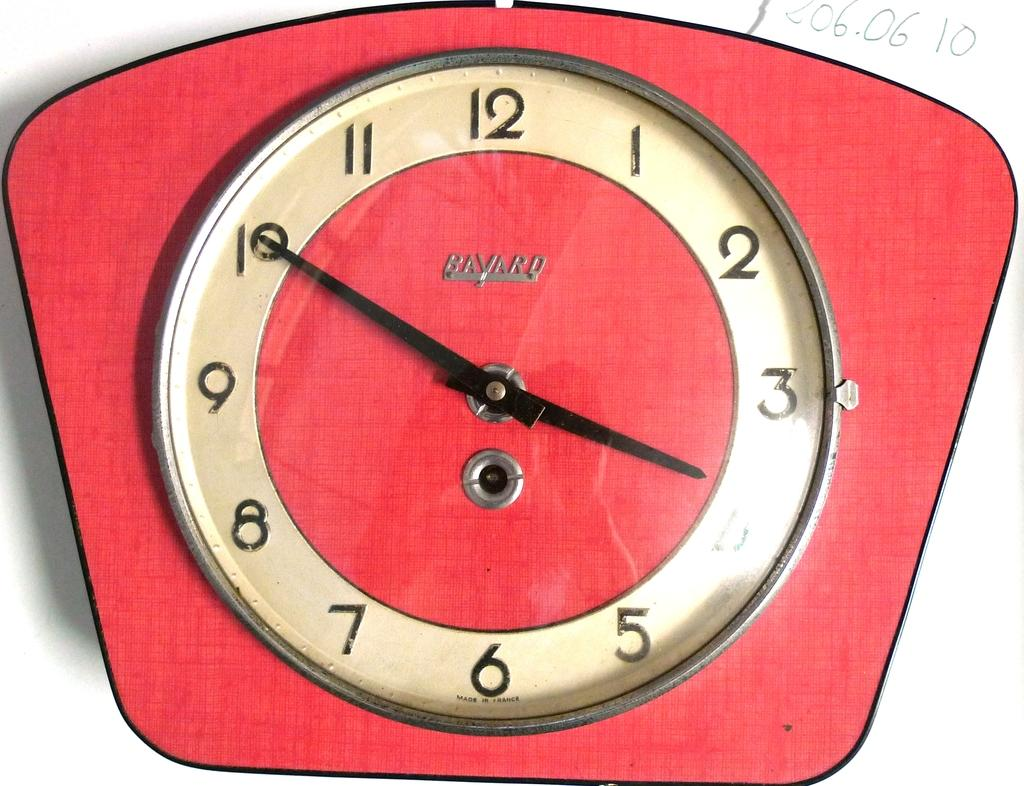Provide a one-sentence caption for the provided image. Red Bavaro clock with the hands at 3:50. 